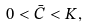Convert formula to latex. <formula><loc_0><loc_0><loc_500><loc_500>0 < \bar { C } < K ,</formula> 